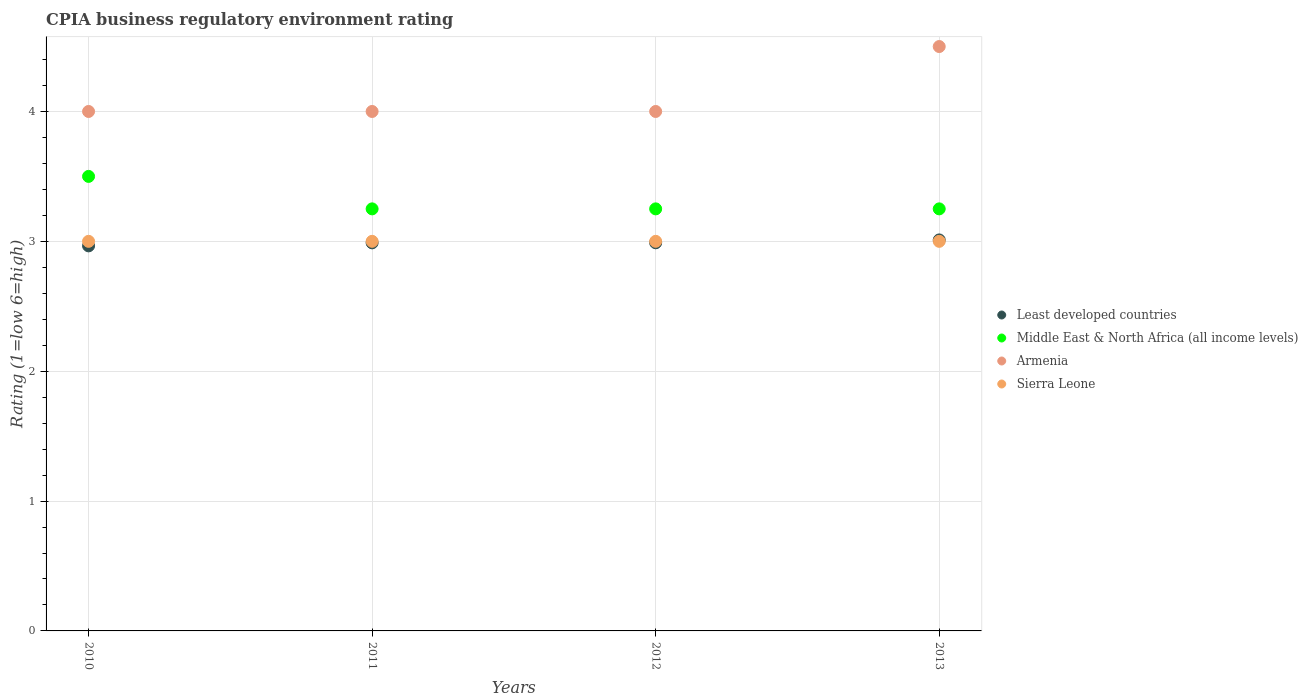What is the CPIA rating in Least developed countries in 2013?
Your answer should be very brief. 3.01. Across all years, what is the maximum CPIA rating in Middle East & North Africa (all income levels)?
Offer a terse response. 3.5. In which year was the CPIA rating in Sierra Leone maximum?
Your response must be concise. 2010. In which year was the CPIA rating in Middle East & North Africa (all income levels) minimum?
Provide a short and direct response. 2011. What is the difference between the CPIA rating in Least developed countries in 2010 and that in 2013?
Make the answer very short. -0.05. What is the difference between the CPIA rating in Least developed countries in 2013 and the CPIA rating in Middle East & North Africa (all income levels) in 2012?
Make the answer very short. -0.24. What is the average CPIA rating in Sierra Leone per year?
Your answer should be very brief. 3. In the year 2012, what is the difference between the CPIA rating in Middle East & North Africa (all income levels) and CPIA rating in Armenia?
Keep it short and to the point. -0.75. What is the ratio of the CPIA rating in Least developed countries in 2012 to that in 2013?
Keep it short and to the point. 0.99. Is the CPIA rating in Least developed countries in 2010 less than that in 2013?
Your answer should be compact. Yes. In how many years, is the CPIA rating in Middle East & North Africa (all income levels) greater than the average CPIA rating in Middle East & North Africa (all income levels) taken over all years?
Provide a short and direct response. 1. Is the sum of the CPIA rating in Least developed countries in 2011 and 2012 greater than the maximum CPIA rating in Sierra Leone across all years?
Offer a terse response. Yes. Is it the case that in every year, the sum of the CPIA rating in Middle East & North Africa (all income levels) and CPIA rating in Armenia  is greater than the CPIA rating in Least developed countries?
Your answer should be compact. Yes. Is the CPIA rating in Armenia strictly greater than the CPIA rating in Sierra Leone over the years?
Make the answer very short. Yes. Is the CPIA rating in Least developed countries strictly less than the CPIA rating in Middle East & North Africa (all income levels) over the years?
Offer a terse response. Yes. Does the graph contain any zero values?
Provide a succinct answer. No. Does the graph contain grids?
Make the answer very short. Yes. What is the title of the graph?
Your response must be concise. CPIA business regulatory environment rating. What is the label or title of the X-axis?
Your answer should be very brief. Years. What is the label or title of the Y-axis?
Offer a very short reply. Rating (1=low 6=high). What is the Rating (1=low 6=high) in Least developed countries in 2010?
Your answer should be very brief. 2.97. What is the Rating (1=low 6=high) in Middle East & North Africa (all income levels) in 2010?
Provide a short and direct response. 3.5. What is the Rating (1=low 6=high) in Sierra Leone in 2010?
Ensure brevity in your answer.  3. What is the Rating (1=low 6=high) of Least developed countries in 2011?
Your answer should be very brief. 2.99. What is the Rating (1=low 6=high) in Middle East & North Africa (all income levels) in 2011?
Your answer should be very brief. 3.25. What is the Rating (1=low 6=high) in Armenia in 2011?
Give a very brief answer. 4. What is the Rating (1=low 6=high) in Least developed countries in 2012?
Your answer should be very brief. 2.99. What is the Rating (1=low 6=high) in Middle East & North Africa (all income levels) in 2012?
Offer a terse response. 3.25. What is the Rating (1=low 6=high) of Armenia in 2012?
Keep it short and to the point. 4. What is the Rating (1=low 6=high) of Least developed countries in 2013?
Keep it short and to the point. 3.01. What is the Rating (1=low 6=high) of Armenia in 2013?
Your response must be concise. 4.5. What is the Rating (1=low 6=high) of Sierra Leone in 2013?
Ensure brevity in your answer.  3. Across all years, what is the maximum Rating (1=low 6=high) of Least developed countries?
Provide a succinct answer. 3.01. Across all years, what is the maximum Rating (1=low 6=high) in Middle East & North Africa (all income levels)?
Provide a succinct answer. 3.5. Across all years, what is the maximum Rating (1=low 6=high) in Armenia?
Make the answer very short. 4.5. Across all years, what is the minimum Rating (1=low 6=high) in Least developed countries?
Provide a succinct answer. 2.97. Across all years, what is the minimum Rating (1=low 6=high) of Middle East & North Africa (all income levels)?
Offer a terse response. 3.25. Across all years, what is the minimum Rating (1=low 6=high) in Armenia?
Your answer should be compact. 4. What is the total Rating (1=low 6=high) of Least developed countries in the graph?
Your answer should be compact. 11.95. What is the total Rating (1=low 6=high) in Middle East & North Africa (all income levels) in the graph?
Your response must be concise. 13.25. What is the total Rating (1=low 6=high) in Sierra Leone in the graph?
Offer a very short reply. 12. What is the difference between the Rating (1=low 6=high) in Least developed countries in 2010 and that in 2011?
Offer a very short reply. -0.02. What is the difference between the Rating (1=low 6=high) of Least developed countries in 2010 and that in 2012?
Provide a succinct answer. -0.02. What is the difference between the Rating (1=low 6=high) in Middle East & North Africa (all income levels) in 2010 and that in 2012?
Your answer should be very brief. 0.25. What is the difference between the Rating (1=low 6=high) of Least developed countries in 2010 and that in 2013?
Provide a short and direct response. -0.05. What is the difference between the Rating (1=low 6=high) in Middle East & North Africa (all income levels) in 2010 and that in 2013?
Make the answer very short. 0.25. What is the difference between the Rating (1=low 6=high) of Armenia in 2010 and that in 2013?
Your answer should be compact. -0.5. What is the difference between the Rating (1=low 6=high) of Least developed countries in 2011 and that in 2012?
Your answer should be very brief. -0. What is the difference between the Rating (1=low 6=high) in Middle East & North Africa (all income levels) in 2011 and that in 2012?
Give a very brief answer. 0. What is the difference between the Rating (1=low 6=high) in Armenia in 2011 and that in 2012?
Offer a very short reply. 0. What is the difference between the Rating (1=low 6=high) in Least developed countries in 2011 and that in 2013?
Your answer should be very brief. -0.02. What is the difference between the Rating (1=low 6=high) in Middle East & North Africa (all income levels) in 2011 and that in 2013?
Your response must be concise. 0. What is the difference between the Rating (1=low 6=high) in Least developed countries in 2012 and that in 2013?
Provide a short and direct response. -0.02. What is the difference between the Rating (1=low 6=high) in Middle East & North Africa (all income levels) in 2012 and that in 2013?
Your answer should be very brief. 0. What is the difference between the Rating (1=low 6=high) in Armenia in 2012 and that in 2013?
Your response must be concise. -0.5. What is the difference between the Rating (1=low 6=high) in Sierra Leone in 2012 and that in 2013?
Keep it short and to the point. 0. What is the difference between the Rating (1=low 6=high) in Least developed countries in 2010 and the Rating (1=low 6=high) in Middle East & North Africa (all income levels) in 2011?
Your answer should be compact. -0.28. What is the difference between the Rating (1=low 6=high) in Least developed countries in 2010 and the Rating (1=low 6=high) in Armenia in 2011?
Keep it short and to the point. -1.03. What is the difference between the Rating (1=low 6=high) in Least developed countries in 2010 and the Rating (1=low 6=high) in Sierra Leone in 2011?
Keep it short and to the point. -0.03. What is the difference between the Rating (1=low 6=high) in Middle East & North Africa (all income levels) in 2010 and the Rating (1=low 6=high) in Sierra Leone in 2011?
Your response must be concise. 0.5. What is the difference between the Rating (1=low 6=high) of Armenia in 2010 and the Rating (1=low 6=high) of Sierra Leone in 2011?
Your response must be concise. 1. What is the difference between the Rating (1=low 6=high) of Least developed countries in 2010 and the Rating (1=low 6=high) of Middle East & North Africa (all income levels) in 2012?
Your response must be concise. -0.28. What is the difference between the Rating (1=low 6=high) of Least developed countries in 2010 and the Rating (1=low 6=high) of Armenia in 2012?
Offer a very short reply. -1.03. What is the difference between the Rating (1=low 6=high) in Least developed countries in 2010 and the Rating (1=low 6=high) in Sierra Leone in 2012?
Offer a terse response. -0.03. What is the difference between the Rating (1=low 6=high) in Middle East & North Africa (all income levels) in 2010 and the Rating (1=low 6=high) in Armenia in 2012?
Provide a short and direct response. -0.5. What is the difference between the Rating (1=low 6=high) in Least developed countries in 2010 and the Rating (1=low 6=high) in Middle East & North Africa (all income levels) in 2013?
Provide a short and direct response. -0.28. What is the difference between the Rating (1=low 6=high) in Least developed countries in 2010 and the Rating (1=low 6=high) in Armenia in 2013?
Give a very brief answer. -1.53. What is the difference between the Rating (1=low 6=high) in Least developed countries in 2010 and the Rating (1=low 6=high) in Sierra Leone in 2013?
Provide a succinct answer. -0.03. What is the difference between the Rating (1=low 6=high) in Middle East & North Africa (all income levels) in 2010 and the Rating (1=low 6=high) in Sierra Leone in 2013?
Provide a succinct answer. 0.5. What is the difference between the Rating (1=low 6=high) in Armenia in 2010 and the Rating (1=low 6=high) in Sierra Leone in 2013?
Provide a short and direct response. 1. What is the difference between the Rating (1=low 6=high) in Least developed countries in 2011 and the Rating (1=low 6=high) in Middle East & North Africa (all income levels) in 2012?
Your answer should be compact. -0.26. What is the difference between the Rating (1=low 6=high) of Least developed countries in 2011 and the Rating (1=low 6=high) of Armenia in 2012?
Your answer should be very brief. -1.01. What is the difference between the Rating (1=low 6=high) in Least developed countries in 2011 and the Rating (1=low 6=high) in Sierra Leone in 2012?
Your response must be concise. -0.01. What is the difference between the Rating (1=low 6=high) of Middle East & North Africa (all income levels) in 2011 and the Rating (1=low 6=high) of Armenia in 2012?
Your answer should be compact. -0.75. What is the difference between the Rating (1=low 6=high) in Least developed countries in 2011 and the Rating (1=low 6=high) in Middle East & North Africa (all income levels) in 2013?
Give a very brief answer. -0.26. What is the difference between the Rating (1=low 6=high) of Least developed countries in 2011 and the Rating (1=low 6=high) of Armenia in 2013?
Your answer should be compact. -1.51. What is the difference between the Rating (1=low 6=high) in Least developed countries in 2011 and the Rating (1=low 6=high) in Sierra Leone in 2013?
Provide a succinct answer. -0.01. What is the difference between the Rating (1=low 6=high) of Middle East & North Africa (all income levels) in 2011 and the Rating (1=low 6=high) of Armenia in 2013?
Your answer should be compact. -1.25. What is the difference between the Rating (1=low 6=high) of Least developed countries in 2012 and the Rating (1=low 6=high) of Middle East & North Africa (all income levels) in 2013?
Provide a short and direct response. -0.26. What is the difference between the Rating (1=low 6=high) in Least developed countries in 2012 and the Rating (1=low 6=high) in Armenia in 2013?
Provide a short and direct response. -1.51. What is the difference between the Rating (1=low 6=high) in Least developed countries in 2012 and the Rating (1=low 6=high) in Sierra Leone in 2013?
Provide a short and direct response. -0.01. What is the difference between the Rating (1=low 6=high) in Middle East & North Africa (all income levels) in 2012 and the Rating (1=low 6=high) in Armenia in 2013?
Ensure brevity in your answer.  -1.25. What is the difference between the Rating (1=low 6=high) in Middle East & North Africa (all income levels) in 2012 and the Rating (1=low 6=high) in Sierra Leone in 2013?
Provide a short and direct response. 0.25. What is the difference between the Rating (1=low 6=high) in Armenia in 2012 and the Rating (1=low 6=high) in Sierra Leone in 2013?
Your answer should be very brief. 1. What is the average Rating (1=low 6=high) in Least developed countries per year?
Make the answer very short. 2.99. What is the average Rating (1=low 6=high) in Middle East & North Africa (all income levels) per year?
Make the answer very short. 3.31. What is the average Rating (1=low 6=high) of Armenia per year?
Your answer should be compact. 4.12. What is the average Rating (1=low 6=high) of Sierra Leone per year?
Your response must be concise. 3. In the year 2010, what is the difference between the Rating (1=low 6=high) of Least developed countries and Rating (1=low 6=high) of Middle East & North Africa (all income levels)?
Keep it short and to the point. -0.53. In the year 2010, what is the difference between the Rating (1=low 6=high) in Least developed countries and Rating (1=low 6=high) in Armenia?
Ensure brevity in your answer.  -1.03. In the year 2010, what is the difference between the Rating (1=low 6=high) of Least developed countries and Rating (1=low 6=high) of Sierra Leone?
Your answer should be compact. -0.03. In the year 2010, what is the difference between the Rating (1=low 6=high) of Middle East & North Africa (all income levels) and Rating (1=low 6=high) of Armenia?
Give a very brief answer. -0.5. In the year 2010, what is the difference between the Rating (1=low 6=high) of Middle East & North Africa (all income levels) and Rating (1=low 6=high) of Sierra Leone?
Provide a short and direct response. 0.5. In the year 2011, what is the difference between the Rating (1=low 6=high) of Least developed countries and Rating (1=low 6=high) of Middle East & North Africa (all income levels)?
Your response must be concise. -0.26. In the year 2011, what is the difference between the Rating (1=low 6=high) of Least developed countries and Rating (1=low 6=high) of Armenia?
Provide a succinct answer. -1.01. In the year 2011, what is the difference between the Rating (1=low 6=high) of Least developed countries and Rating (1=low 6=high) of Sierra Leone?
Your answer should be very brief. -0.01. In the year 2011, what is the difference between the Rating (1=low 6=high) in Middle East & North Africa (all income levels) and Rating (1=low 6=high) in Armenia?
Keep it short and to the point. -0.75. In the year 2011, what is the difference between the Rating (1=low 6=high) of Middle East & North Africa (all income levels) and Rating (1=low 6=high) of Sierra Leone?
Make the answer very short. 0.25. In the year 2012, what is the difference between the Rating (1=low 6=high) of Least developed countries and Rating (1=low 6=high) of Middle East & North Africa (all income levels)?
Offer a very short reply. -0.26. In the year 2012, what is the difference between the Rating (1=low 6=high) of Least developed countries and Rating (1=low 6=high) of Armenia?
Give a very brief answer. -1.01. In the year 2012, what is the difference between the Rating (1=low 6=high) in Least developed countries and Rating (1=low 6=high) in Sierra Leone?
Offer a very short reply. -0.01. In the year 2012, what is the difference between the Rating (1=low 6=high) of Middle East & North Africa (all income levels) and Rating (1=low 6=high) of Armenia?
Keep it short and to the point. -0.75. In the year 2012, what is the difference between the Rating (1=low 6=high) of Middle East & North Africa (all income levels) and Rating (1=low 6=high) of Sierra Leone?
Make the answer very short. 0.25. In the year 2012, what is the difference between the Rating (1=low 6=high) in Armenia and Rating (1=low 6=high) in Sierra Leone?
Your response must be concise. 1. In the year 2013, what is the difference between the Rating (1=low 6=high) in Least developed countries and Rating (1=low 6=high) in Middle East & North Africa (all income levels)?
Make the answer very short. -0.24. In the year 2013, what is the difference between the Rating (1=low 6=high) in Least developed countries and Rating (1=low 6=high) in Armenia?
Keep it short and to the point. -1.49. In the year 2013, what is the difference between the Rating (1=low 6=high) in Least developed countries and Rating (1=low 6=high) in Sierra Leone?
Keep it short and to the point. 0.01. In the year 2013, what is the difference between the Rating (1=low 6=high) in Middle East & North Africa (all income levels) and Rating (1=low 6=high) in Armenia?
Your response must be concise. -1.25. In the year 2013, what is the difference between the Rating (1=low 6=high) in Armenia and Rating (1=low 6=high) in Sierra Leone?
Make the answer very short. 1.5. What is the ratio of the Rating (1=low 6=high) of Sierra Leone in 2010 to that in 2011?
Your answer should be compact. 1. What is the ratio of the Rating (1=low 6=high) in Middle East & North Africa (all income levels) in 2010 to that in 2012?
Your answer should be very brief. 1.08. What is the ratio of the Rating (1=low 6=high) of Armenia in 2010 to that in 2012?
Your answer should be compact. 1. What is the ratio of the Rating (1=low 6=high) in Least developed countries in 2010 to that in 2013?
Offer a very short reply. 0.98. What is the ratio of the Rating (1=low 6=high) in Middle East & North Africa (all income levels) in 2010 to that in 2013?
Your answer should be very brief. 1.08. What is the ratio of the Rating (1=low 6=high) of Armenia in 2010 to that in 2013?
Ensure brevity in your answer.  0.89. What is the ratio of the Rating (1=low 6=high) in Sierra Leone in 2010 to that in 2013?
Provide a succinct answer. 1. What is the ratio of the Rating (1=low 6=high) of Middle East & North Africa (all income levels) in 2011 to that in 2012?
Your response must be concise. 1. What is the ratio of the Rating (1=low 6=high) of Sierra Leone in 2011 to that in 2012?
Your answer should be very brief. 1. What is the ratio of the Rating (1=low 6=high) in Middle East & North Africa (all income levels) in 2011 to that in 2013?
Offer a terse response. 1. What is the ratio of the Rating (1=low 6=high) in Sierra Leone in 2011 to that in 2013?
Offer a terse response. 1. What is the ratio of the Rating (1=low 6=high) of Armenia in 2012 to that in 2013?
Offer a very short reply. 0.89. What is the ratio of the Rating (1=low 6=high) in Sierra Leone in 2012 to that in 2013?
Your response must be concise. 1. What is the difference between the highest and the second highest Rating (1=low 6=high) in Least developed countries?
Provide a short and direct response. 0.02. What is the difference between the highest and the second highest Rating (1=low 6=high) in Middle East & North Africa (all income levels)?
Your response must be concise. 0.25. What is the difference between the highest and the lowest Rating (1=low 6=high) in Least developed countries?
Keep it short and to the point. 0.05. What is the difference between the highest and the lowest Rating (1=low 6=high) in Middle East & North Africa (all income levels)?
Provide a succinct answer. 0.25. What is the difference between the highest and the lowest Rating (1=low 6=high) in Sierra Leone?
Your answer should be very brief. 0. 